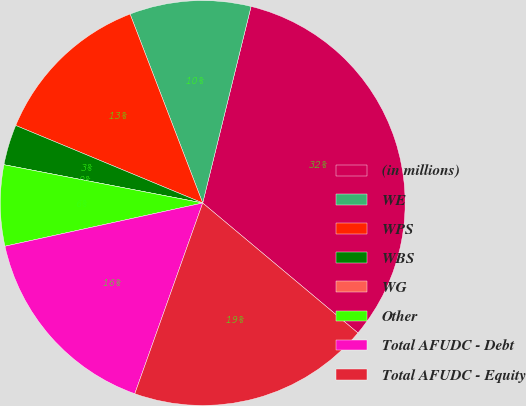Convert chart. <chart><loc_0><loc_0><loc_500><loc_500><pie_chart><fcel>(in millions)<fcel>WE<fcel>WPS<fcel>WBS<fcel>WG<fcel>Other<fcel>Total AFUDC - Debt<fcel>Total AFUDC - Equity<nl><fcel>32.25%<fcel>9.68%<fcel>12.9%<fcel>3.23%<fcel>0.0%<fcel>6.45%<fcel>16.13%<fcel>19.35%<nl></chart> 